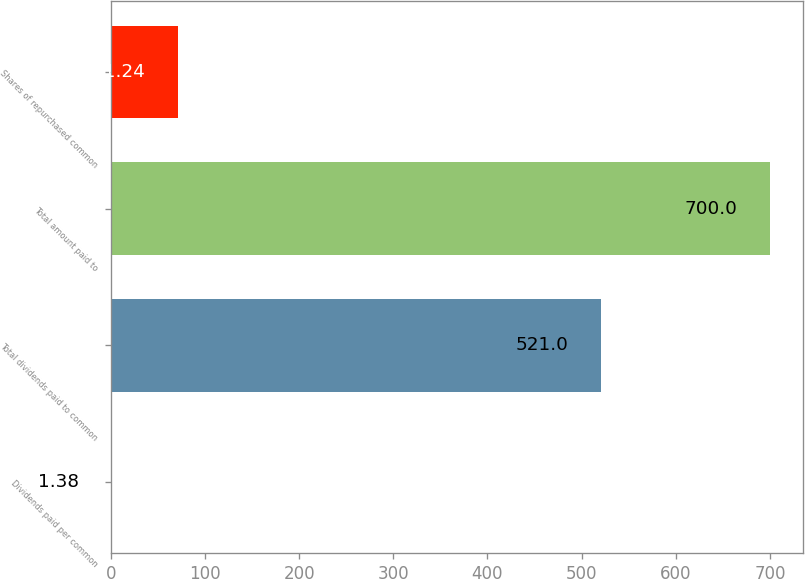Convert chart to OTSL. <chart><loc_0><loc_0><loc_500><loc_500><bar_chart><fcel>Dividends paid per common<fcel>Total dividends paid to common<fcel>Total amount paid to<fcel>Shares of repurchased common<nl><fcel>1.38<fcel>521<fcel>700<fcel>71.24<nl></chart> 